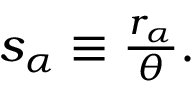<formula> <loc_0><loc_0><loc_500><loc_500>\begin{array} { r } { s _ { \alpha } \equiv \frac { r _ { \alpha } } { \theta } . } \end{array}</formula> 